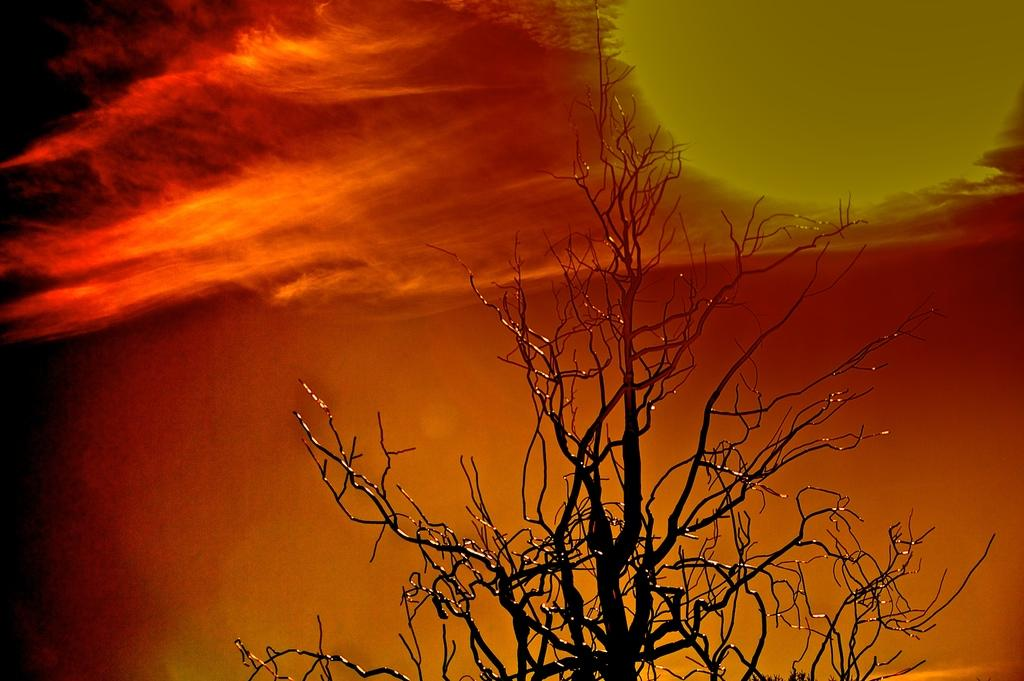What is the main subject in the center of the image? There is a tree without leaves in the center of the image. What can be seen in the background of the image? The sky is visible in the background of the image. Where is the sun located in the image? The sun is on the right side of the image. What is present on the left side of the image? There are clouds on the left side of the image. What type of vase is placed on the cent of the tree in the image? There is no vase present on the tree in the image; it is a bare tree without leaves. 